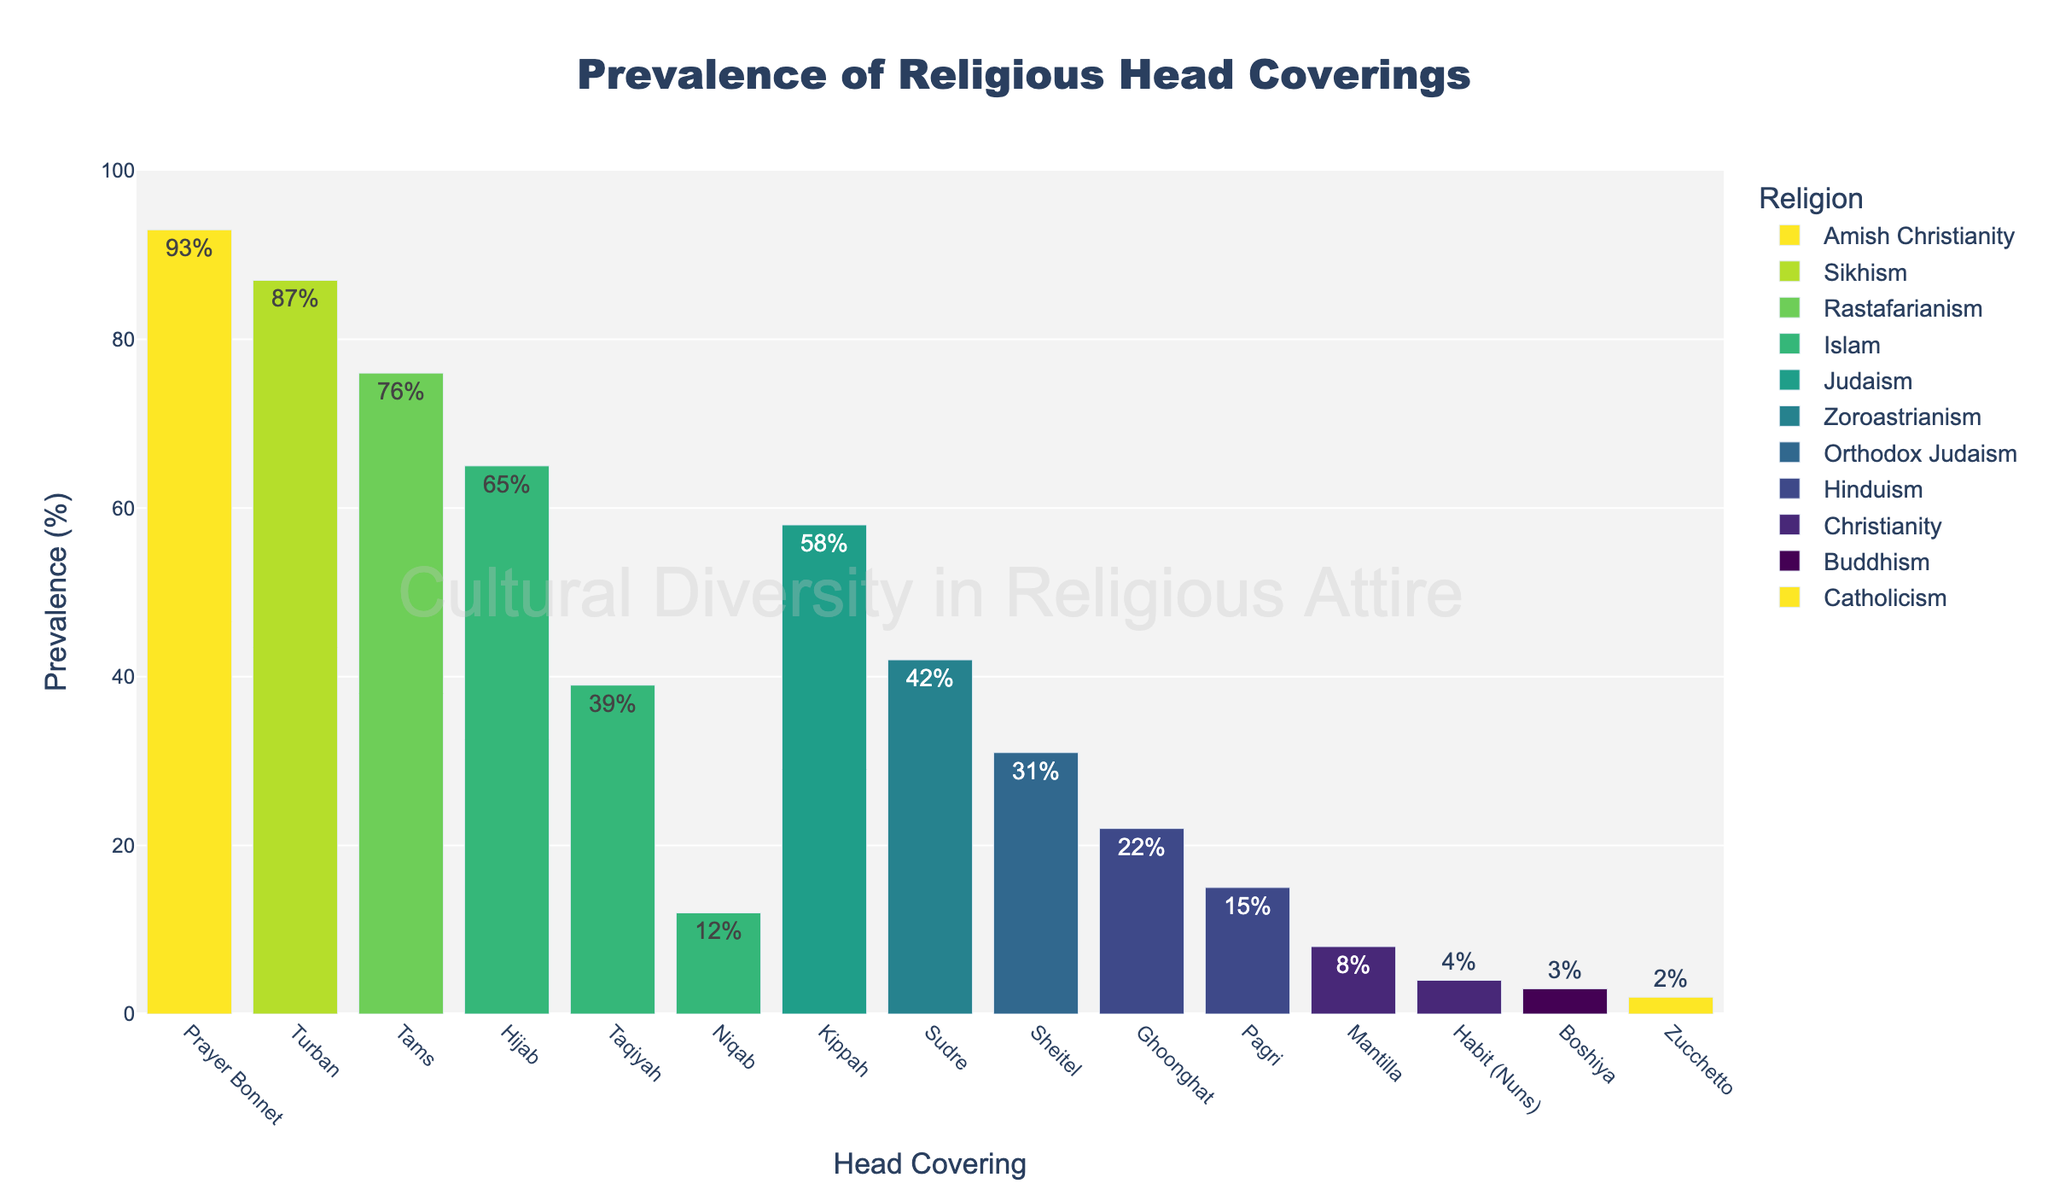What head covering has the highest prevalence across all religions? To determine the head covering with the highest prevalence, examine each bar and find the tallest one. The highest bar represents the Sikh Turban with a prevalence of 87%.
Answer: Sikh Turban Which religious group has the head covering with the lowest prevalence? Inspect all the bars to find the shortest one. The shortest bar corresponds to the Buddhist Boshiya with a prevalence of 3%.
Answer: Buddhism (Boshiya) What is the difference in prevalence between the Hijab in Islam and the Kippah in Judaism? Locate the bars for Hijab and Kippah. The Hijab has a prevalence of 65%, and the Kippah has 58%. Calculate the difference: 65% - 58% = 7%.
Answer: 7% Which head covering has a higher prevalence: Mantilla in Christianity or Ghoonghat in Hinduism? Compare the heights of the bars for Mantilla and Ghoonghat. The Mantilla has a prevalence of 8%, while the Ghoonghat has 22%. Thus, Ghoonghat is higher.
Answer: Ghoonghat What is the average prevalence of head coverings in Christianity? In Christianity, the head coverings listed are Habit (4%), Mantilla (8%), and Zucchetto (2%). Calculate the average: (4% + 8% + 2%) / 3 = 4.67%.
Answer: 4.67% Which religion has more than one head covering with its prevalence listed? Identify the religions mentioned multiple times in the data. Islam is mentioned with Hijab (65%), Niqab (12%), and Taqiyah (39%).
Answer: Islam Between Amish Christianity's Prayer Bonnet and Rastafarianism Tams, which has a higher prevalence, and by how much? Compare the prevalence of Prayer Bonnet (93%) and Tams (76%). Calculate the difference: 93% - 76% = 17%.
Answer: Prayer Bonnet, 17% If we combine the prevalence of all head coverings in Hinduism, what is the total? Sum the prevalences of head coverings listed under Hinduism: Ghoonghat (22%) and Pagri (15%). Total: 22% + 15% = 37%.
Answer: 37% 